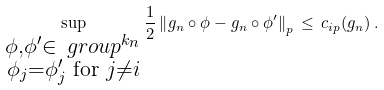<formula> <loc_0><loc_0><loc_500><loc_500>\sup _ { \substack { \phi , \phi ^ { \prime } \in \ g r o u p ^ { k _ { n } } \\ \phi _ { j } = \phi ^ { \prime } _ { j } \text { for } j \neq i } } \frac { 1 } { 2 } \left \| g _ { n } \circ \phi - g _ { n } \circ \phi ^ { \prime } \right \| _ { p } \, \leq \, c _ { i p } ( g _ { n } ) \, .</formula> 